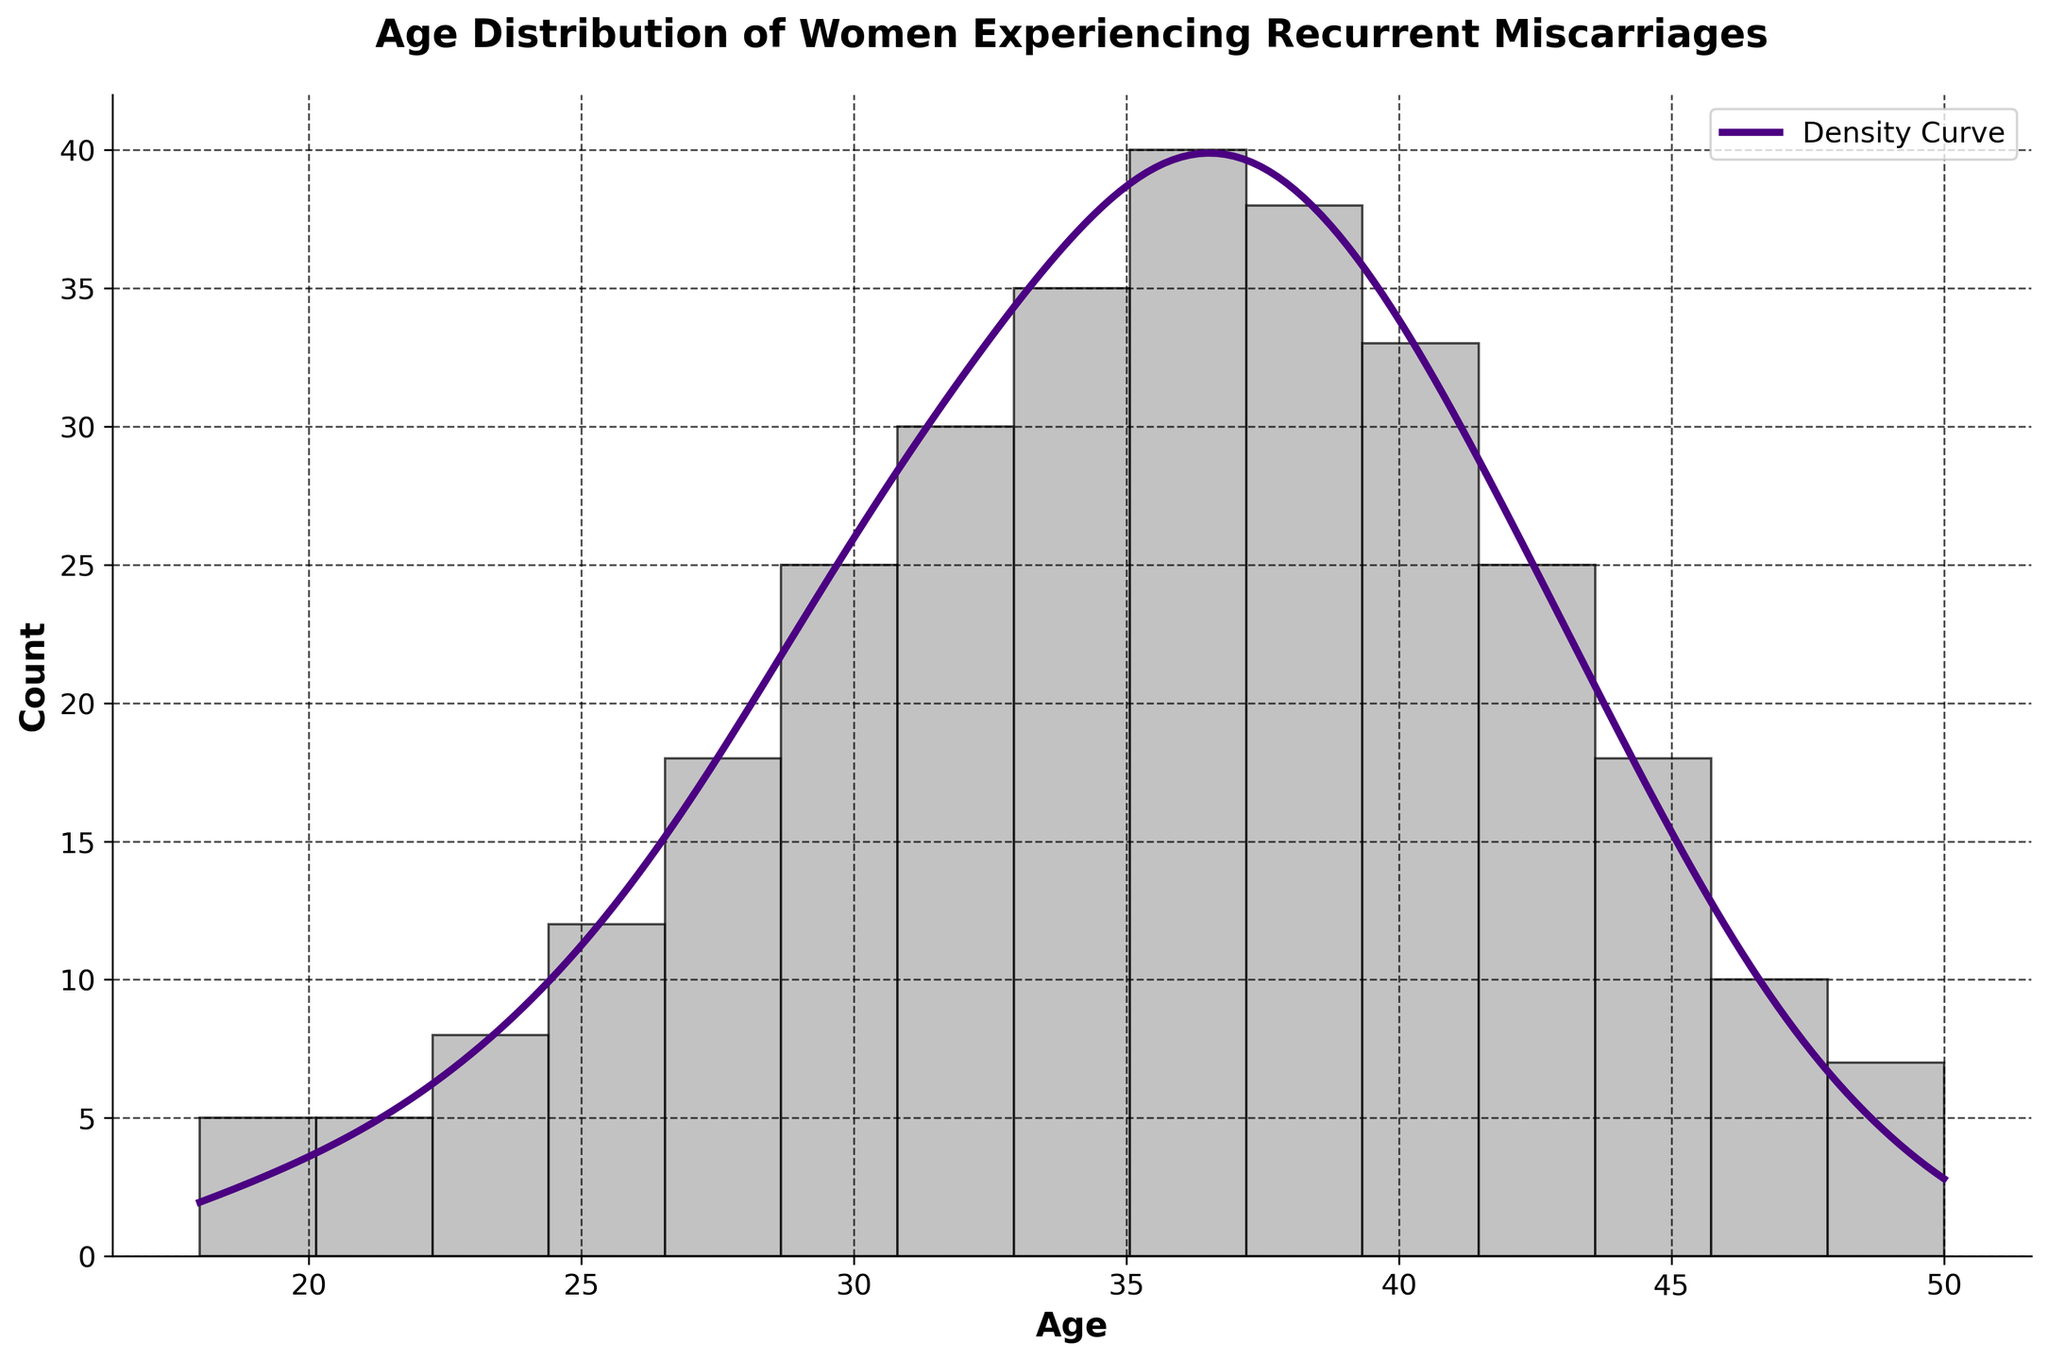What is the peak age group for women experiencing recurrent miscarriages according to the density curve? The peak age group for women experiencing recurrent miscarriages can be identified by looking at the maximum value of the density curve (purple line). The highest density occurs at around 36 years old.
Answer: Around 36 years old What are the age ranges where the counts are noticeably high? By observing the histogram bars, the counts are noticeably high in the age ranges of 30–40 years old. These bars are taller compared to other age groups.
Answer: 30–40 years old Which age has the lowest count of women experiencing recurrent miscarriages? By looking at the histogram, the ages with the lowest count are 18 and 50, each having the smallest bar height.
Answer: 18 and 50 How does the number of women aged 38 compare to the number of women aged 28 experiencing recurrent miscarriages? The histogram shows that the count for age 38 is higher than for age 28. Both the bar height for age 38 is clearly taller than that of age 28.
Answer: Higher for age 38 What is the overall trend in miscarriage counts as age increases? Observing the histogram, the counts generally increase from ages 18 to 36, peak around 36, and then decrease as age approaches 50.
Answer: Increases to 36, then decreases Which age group shows a noticeable dip in the density curve? The density curve (purple line) shows a noticeable dip around the age of 42.
Answer: Around 42 What is the count of miscarriages for women aged 40? By looking at the histogram bar for age 40, the count appears to be around 33.
Answer: Around 33 Between what ages does the density curve sharply rise? The density curve shows a sharp rise from around the age of 24 to 36.
Answer: 24 to 36 How does the area under the density curve for ages 30-40 compare to that of ages 42-50? The area under the density curve for ages 30-40 is larger compared to that of ages 42-50, indicating a higher probability density.
Answer: Larger for ages 30-40 What can be inferred about the frequency of miscarriages for women in their 20s versus those in their 30s? The histogram shows that the count of miscarriages is higher for women in their 30s compared to those in their 20s, as indicated by taller bars in the 30s group.
Answer: Higher in their 30s 